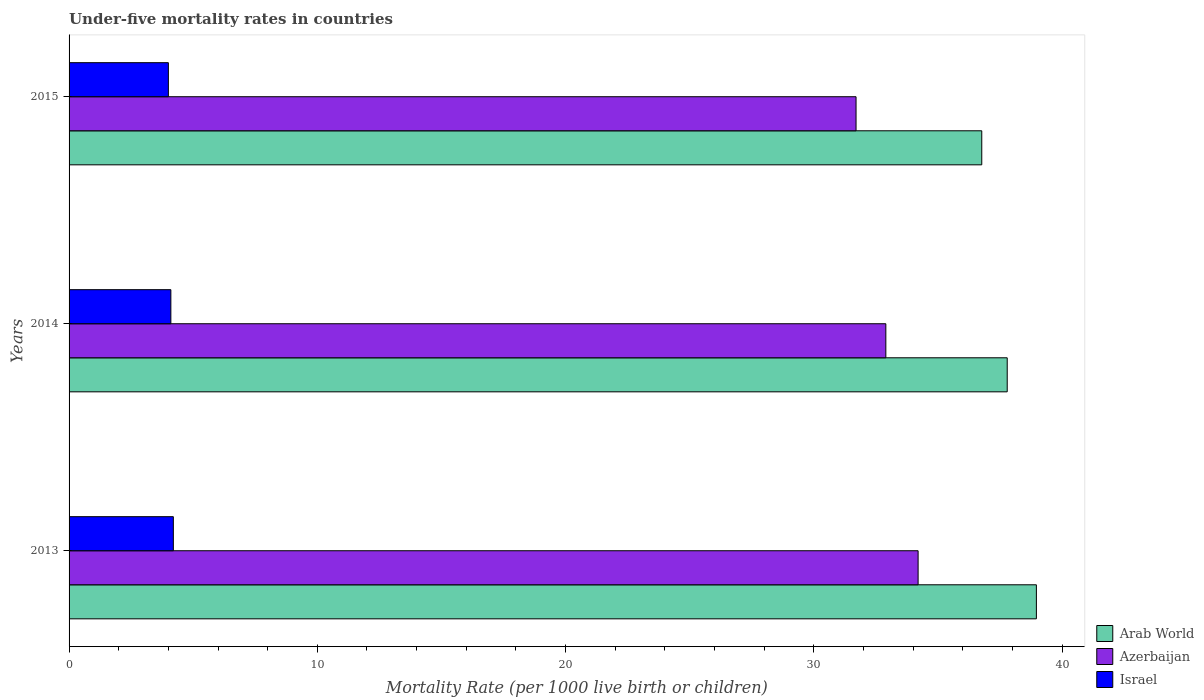How many different coloured bars are there?
Ensure brevity in your answer.  3. How many groups of bars are there?
Provide a succinct answer. 3. How many bars are there on the 1st tick from the bottom?
Your answer should be compact. 3. In how many cases, is the number of bars for a given year not equal to the number of legend labels?
Provide a short and direct response. 0. Across all years, what is the maximum under-five mortality rate in Azerbaijan?
Provide a succinct answer. 34.2. Across all years, what is the minimum under-five mortality rate in Azerbaijan?
Provide a short and direct response. 31.7. In which year was the under-five mortality rate in Arab World minimum?
Offer a terse response. 2015. What is the total under-five mortality rate in Azerbaijan in the graph?
Keep it short and to the point. 98.8. What is the difference between the under-five mortality rate in Azerbaijan in 2014 and that in 2015?
Keep it short and to the point. 1.2. What is the difference between the under-five mortality rate in Azerbaijan in 2014 and the under-five mortality rate in Israel in 2015?
Make the answer very short. 28.9. What is the average under-five mortality rate in Azerbaijan per year?
Give a very brief answer. 32.93. In the year 2013, what is the difference between the under-five mortality rate in Azerbaijan and under-five mortality rate in Israel?
Offer a terse response. 30. In how many years, is the under-five mortality rate in Azerbaijan greater than 2 ?
Your response must be concise. 3. What is the ratio of the under-five mortality rate in Azerbaijan in 2013 to that in 2015?
Your answer should be very brief. 1.08. Is the difference between the under-five mortality rate in Azerbaijan in 2014 and 2015 greater than the difference between the under-five mortality rate in Israel in 2014 and 2015?
Your answer should be very brief. Yes. What is the difference between the highest and the second highest under-five mortality rate in Arab World?
Give a very brief answer. 1.18. What is the difference between the highest and the lowest under-five mortality rate in Arab World?
Provide a succinct answer. 2.2. Is the sum of the under-five mortality rate in Arab World in 2014 and 2015 greater than the maximum under-five mortality rate in Israel across all years?
Your answer should be very brief. Yes. What does the 2nd bar from the top in 2013 represents?
Provide a succinct answer. Azerbaijan. What does the 1st bar from the bottom in 2014 represents?
Make the answer very short. Arab World. Is it the case that in every year, the sum of the under-five mortality rate in Arab World and under-five mortality rate in Israel is greater than the under-five mortality rate in Azerbaijan?
Offer a very short reply. Yes. How many bars are there?
Your answer should be compact. 9. Are all the bars in the graph horizontal?
Make the answer very short. Yes. What is the difference between two consecutive major ticks on the X-axis?
Provide a short and direct response. 10. Does the graph contain any zero values?
Your response must be concise. No. Where does the legend appear in the graph?
Give a very brief answer. Bottom right. What is the title of the graph?
Your answer should be very brief. Under-five mortality rates in countries. Does "High income: OECD" appear as one of the legend labels in the graph?
Keep it short and to the point. No. What is the label or title of the X-axis?
Make the answer very short. Mortality Rate (per 1000 live birth or children). What is the label or title of the Y-axis?
Offer a very short reply. Years. What is the Mortality Rate (per 1000 live birth or children) in Arab World in 2013?
Give a very brief answer. 38.96. What is the Mortality Rate (per 1000 live birth or children) of Azerbaijan in 2013?
Offer a terse response. 34.2. What is the Mortality Rate (per 1000 live birth or children) of Israel in 2013?
Give a very brief answer. 4.2. What is the Mortality Rate (per 1000 live birth or children) in Arab World in 2014?
Make the answer very short. 37.79. What is the Mortality Rate (per 1000 live birth or children) in Azerbaijan in 2014?
Offer a terse response. 32.9. What is the Mortality Rate (per 1000 live birth or children) in Arab World in 2015?
Your response must be concise. 36.76. What is the Mortality Rate (per 1000 live birth or children) in Azerbaijan in 2015?
Make the answer very short. 31.7. Across all years, what is the maximum Mortality Rate (per 1000 live birth or children) in Arab World?
Your response must be concise. 38.96. Across all years, what is the maximum Mortality Rate (per 1000 live birth or children) in Azerbaijan?
Make the answer very short. 34.2. Across all years, what is the maximum Mortality Rate (per 1000 live birth or children) of Israel?
Offer a very short reply. 4.2. Across all years, what is the minimum Mortality Rate (per 1000 live birth or children) in Arab World?
Make the answer very short. 36.76. Across all years, what is the minimum Mortality Rate (per 1000 live birth or children) of Azerbaijan?
Offer a very short reply. 31.7. What is the total Mortality Rate (per 1000 live birth or children) in Arab World in the graph?
Your answer should be compact. 113.52. What is the total Mortality Rate (per 1000 live birth or children) of Azerbaijan in the graph?
Provide a short and direct response. 98.8. What is the difference between the Mortality Rate (per 1000 live birth or children) of Arab World in 2013 and that in 2014?
Keep it short and to the point. 1.18. What is the difference between the Mortality Rate (per 1000 live birth or children) of Arab World in 2013 and that in 2015?
Your answer should be very brief. 2.2. What is the difference between the Mortality Rate (per 1000 live birth or children) of Arab World in 2014 and that in 2015?
Offer a very short reply. 1.03. What is the difference between the Mortality Rate (per 1000 live birth or children) in Azerbaijan in 2014 and that in 2015?
Your answer should be compact. 1.2. What is the difference between the Mortality Rate (per 1000 live birth or children) in Israel in 2014 and that in 2015?
Provide a succinct answer. 0.1. What is the difference between the Mortality Rate (per 1000 live birth or children) of Arab World in 2013 and the Mortality Rate (per 1000 live birth or children) of Azerbaijan in 2014?
Give a very brief answer. 6.06. What is the difference between the Mortality Rate (per 1000 live birth or children) in Arab World in 2013 and the Mortality Rate (per 1000 live birth or children) in Israel in 2014?
Provide a succinct answer. 34.86. What is the difference between the Mortality Rate (per 1000 live birth or children) in Azerbaijan in 2013 and the Mortality Rate (per 1000 live birth or children) in Israel in 2014?
Provide a succinct answer. 30.1. What is the difference between the Mortality Rate (per 1000 live birth or children) of Arab World in 2013 and the Mortality Rate (per 1000 live birth or children) of Azerbaijan in 2015?
Your response must be concise. 7.26. What is the difference between the Mortality Rate (per 1000 live birth or children) of Arab World in 2013 and the Mortality Rate (per 1000 live birth or children) of Israel in 2015?
Provide a short and direct response. 34.96. What is the difference between the Mortality Rate (per 1000 live birth or children) of Azerbaijan in 2013 and the Mortality Rate (per 1000 live birth or children) of Israel in 2015?
Keep it short and to the point. 30.2. What is the difference between the Mortality Rate (per 1000 live birth or children) of Arab World in 2014 and the Mortality Rate (per 1000 live birth or children) of Azerbaijan in 2015?
Make the answer very short. 6.09. What is the difference between the Mortality Rate (per 1000 live birth or children) of Arab World in 2014 and the Mortality Rate (per 1000 live birth or children) of Israel in 2015?
Provide a short and direct response. 33.79. What is the difference between the Mortality Rate (per 1000 live birth or children) of Azerbaijan in 2014 and the Mortality Rate (per 1000 live birth or children) of Israel in 2015?
Your response must be concise. 28.9. What is the average Mortality Rate (per 1000 live birth or children) of Arab World per year?
Provide a short and direct response. 37.84. What is the average Mortality Rate (per 1000 live birth or children) of Azerbaijan per year?
Your response must be concise. 32.93. In the year 2013, what is the difference between the Mortality Rate (per 1000 live birth or children) of Arab World and Mortality Rate (per 1000 live birth or children) of Azerbaijan?
Make the answer very short. 4.76. In the year 2013, what is the difference between the Mortality Rate (per 1000 live birth or children) in Arab World and Mortality Rate (per 1000 live birth or children) in Israel?
Keep it short and to the point. 34.76. In the year 2013, what is the difference between the Mortality Rate (per 1000 live birth or children) in Azerbaijan and Mortality Rate (per 1000 live birth or children) in Israel?
Your response must be concise. 30. In the year 2014, what is the difference between the Mortality Rate (per 1000 live birth or children) in Arab World and Mortality Rate (per 1000 live birth or children) in Azerbaijan?
Keep it short and to the point. 4.89. In the year 2014, what is the difference between the Mortality Rate (per 1000 live birth or children) of Arab World and Mortality Rate (per 1000 live birth or children) of Israel?
Your answer should be very brief. 33.69. In the year 2014, what is the difference between the Mortality Rate (per 1000 live birth or children) of Azerbaijan and Mortality Rate (per 1000 live birth or children) of Israel?
Your answer should be very brief. 28.8. In the year 2015, what is the difference between the Mortality Rate (per 1000 live birth or children) of Arab World and Mortality Rate (per 1000 live birth or children) of Azerbaijan?
Offer a terse response. 5.06. In the year 2015, what is the difference between the Mortality Rate (per 1000 live birth or children) in Arab World and Mortality Rate (per 1000 live birth or children) in Israel?
Offer a terse response. 32.76. In the year 2015, what is the difference between the Mortality Rate (per 1000 live birth or children) in Azerbaijan and Mortality Rate (per 1000 live birth or children) in Israel?
Your answer should be compact. 27.7. What is the ratio of the Mortality Rate (per 1000 live birth or children) in Arab World in 2013 to that in 2014?
Ensure brevity in your answer.  1.03. What is the ratio of the Mortality Rate (per 1000 live birth or children) in Azerbaijan in 2013 to that in 2014?
Give a very brief answer. 1.04. What is the ratio of the Mortality Rate (per 1000 live birth or children) of Israel in 2013 to that in 2014?
Your answer should be very brief. 1.02. What is the ratio of the Mortality Rate (per 1000 live birth or children) of Arab World in 2013 to that in 2015?
Your response must be concise. 1.06. What is the ratio of the Mortality Rate (per 1000 live birth or children) in Azerbaijan in 2013 to that in 2015?
Make the answer very short. 1.08. What is the ratio of the Mortality Rate (per 1000 live birth or children) of Arab World in 2014 to that in 2015?
Give a very brief answer. 1.03. What is the ratio of the Mortality Rate (per 1000 live birth or children) of Azerbaijan in 2014 to that in 2015?
Provide a short and direct response. 1.04. What is the difference between the highest and the second highest Mortality Rate (per 1000 live birth or children) of Arab World?
Provide a succinct answer. 1.18. What is the difference between the highest and the second highest Mortality Rate (per 1000 live birth or children) of Israel?
Give a very brief answer. 0.1. What is the difference between the highest and the lowest Mortality Rate (per 1000 live birth or children) in Arab World?
Ensure brevity in your answer.  2.2. What is the difference between the highest and the lowest Mortality Rate (per 1000 live birth or children) in Israel?
Your response must be concise. 0.2. 